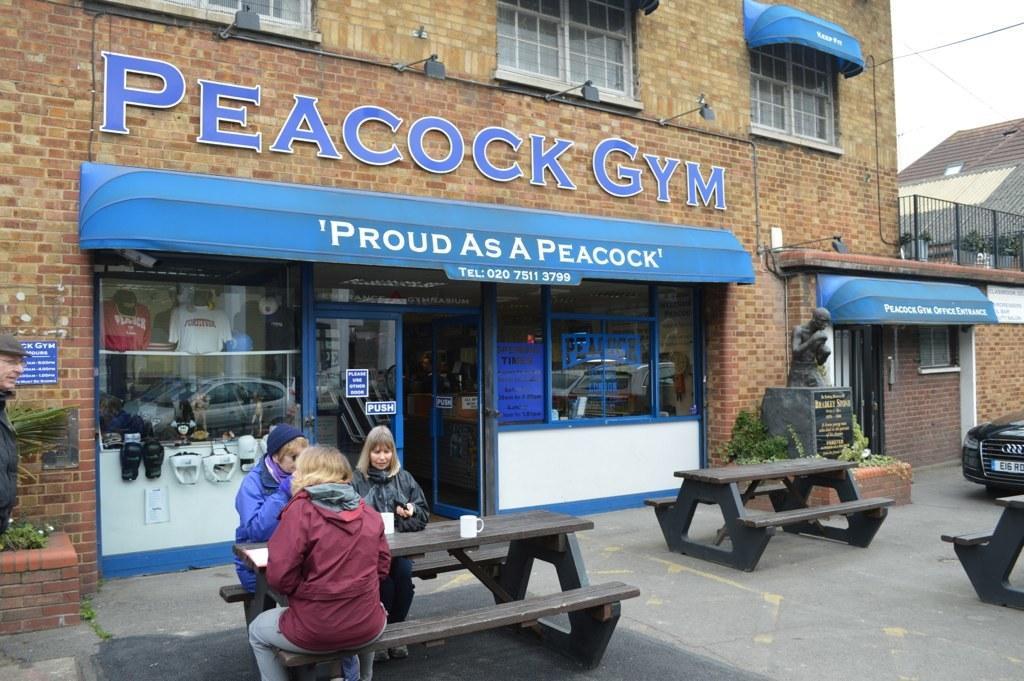Describe this image in one or two sentences. this picture shows a building and we see three people seated on the bench and we see few cups on it and we see a car parked and a statue and we see a man standing 